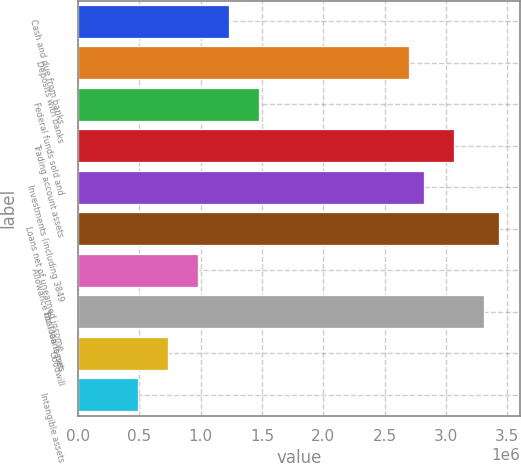<chart> <loc_0><loc_0><loc_500><loc_500><bar_chart><fcel>Cash and due from banks<fcel>Deposits with banks<fcel>Federal funds sold and<fcel>Trading account assets<fcel>Investments (including 3849<fcel>Loans net of unearned income<fcel>Allowance for loan losses<fcel>Total loans net<fcel>Goodwill<fcel>Intangible assets<nl><fcel>1.22704e+06<fcel>2.69859e+06<fcel>1.4723e+06<fcel>3.06647e+06<fcel>2.82122e+06<fcel>3.43436e+06<fcel>981782<fcel>3.31173e+06<fcel>736524<fcel>491267<nl></chart> 